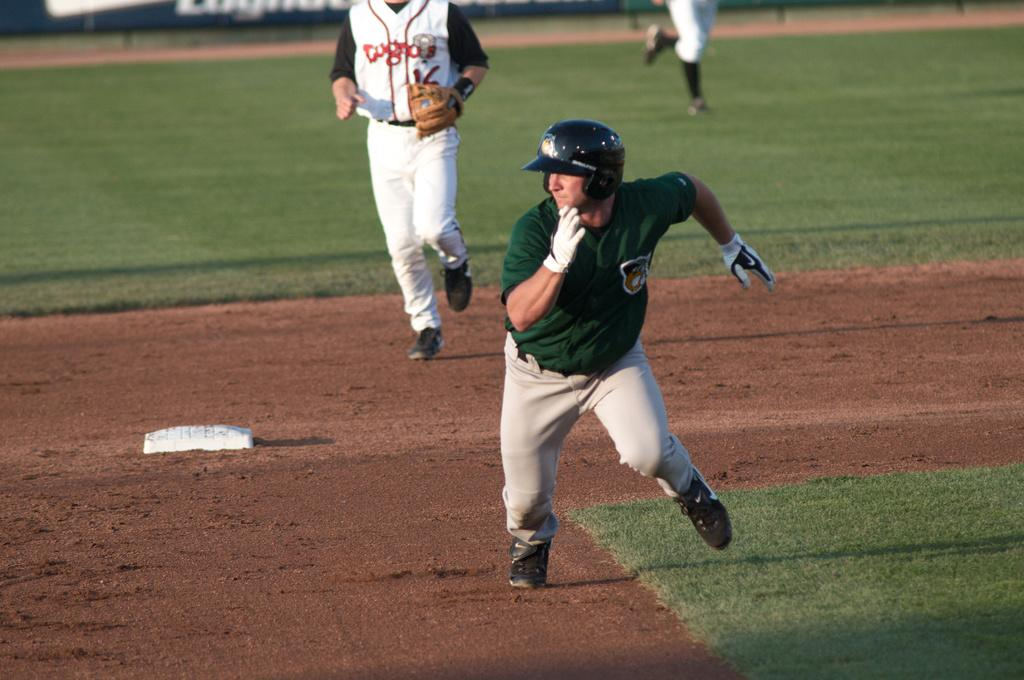What are the two persons in the image doing? The two persons in the image are running. What part of the persons can be seen in the image? Human legs are visible at the top of the image. What type of surface is in the background of the image? There is ground in the background of the image. What type of terrain is present in the background of the image? There is sand in the background of the image. How many houses can be seen in the image? There are no houses visible in the image; it features two persons running on a sandy ground. What type of achievement is being celebrated by the person in the image? There is no person celebrating an achievement in the image; it simply shows two persons running. 